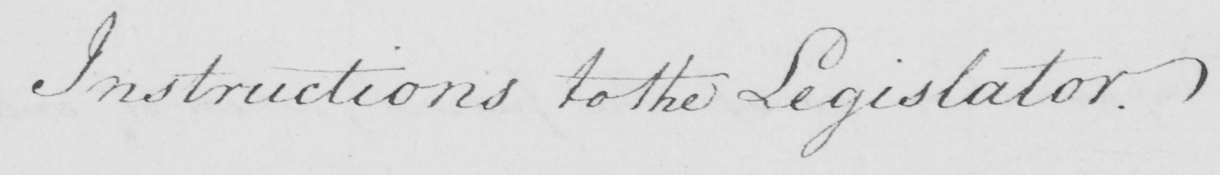What text is written in this handwritten line? Instructions to the Legislator . 